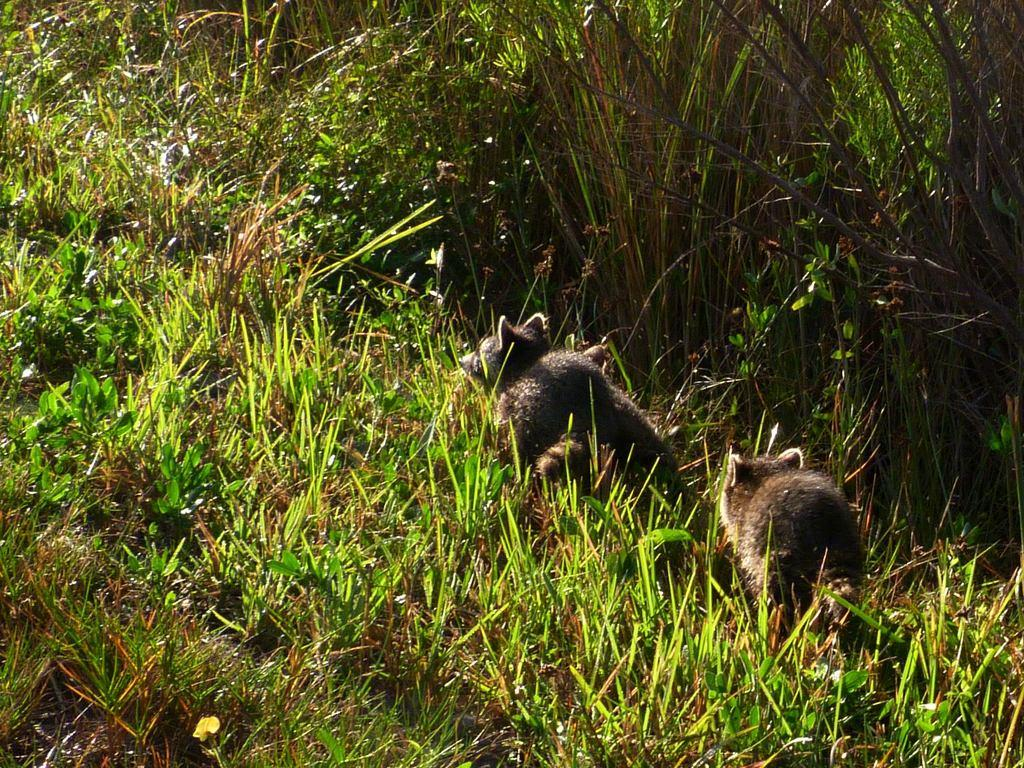What types of living organisms can be seen in the image? Animals can be seen in the image. What is the color of the grass in the image? The grass in the image is green. Can you see any cobwebs in the image? There is no mention of cobwebs in the image, so it cannot be determined if any are present. What is the tendency of the cook in the image? There is no cook present in the image, so it cannot be determined if any tendencies can be observed. 